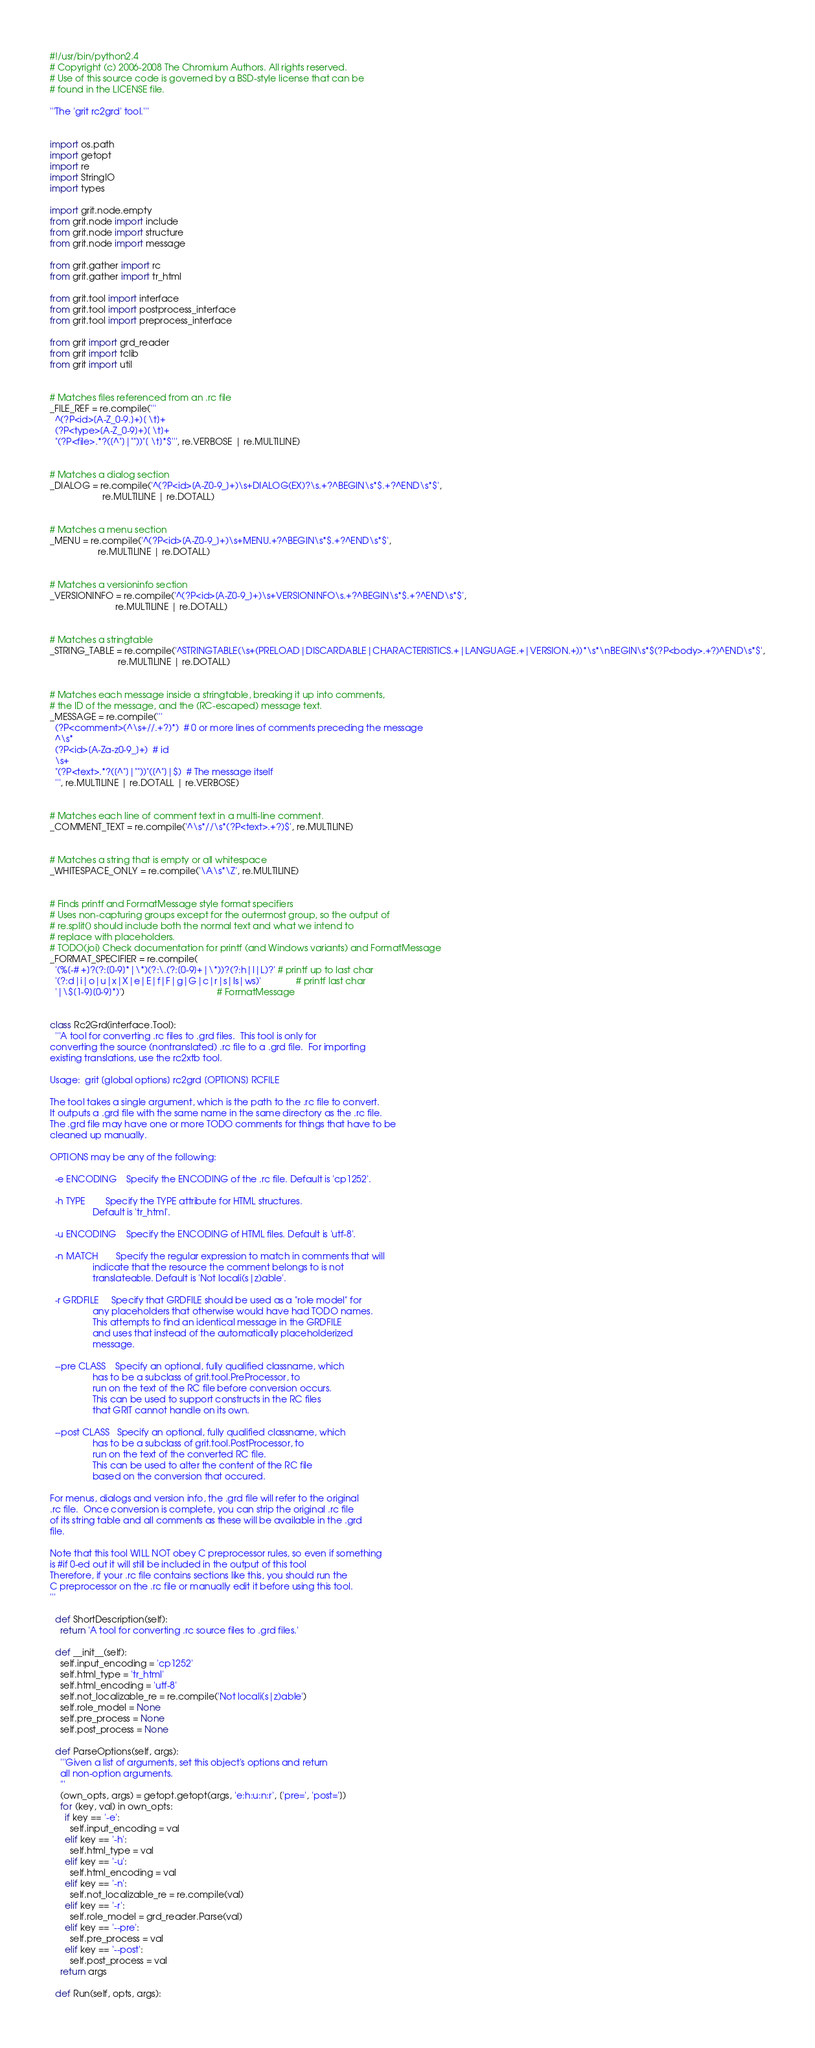Convert code to text. <code><loc_0><loc_0><loc_500><loc_500><_Python_>#!/usr/bin/python2.4
# Copyright (c) 2006-2008 The Chromium Authors. All rights reserved.
# Use of this source code is governed by a BSD-style license that can be
# found in the LICENSE file.

'''The 'grit rc2grd' tool.'''


import os.path
import getopt
import re
import StringIO
import types

import grit.node.empty
from grit.node import include
from grit.node import structure
from grit.node import message

from grit.gather import rc
from grit.gather import tr_html

from grit.tool import interface
from grit.tool import postprocess_interface
from grit.tool import preprocess_interface

from grit import grd_reader
from grit import tclib
from grit import util


# Matches files referenced from an .rc file
_FILE_REF = re.compile('''
  ^(?P<id>[A-Z_0-9.]+)[ \t]+
  (?P<type>[A-Z_0-9]+)[ \t]+
  "(?P<file>.*?([^"]|""))"[ \t]*$''', re.VERBOSE | re.MULTILINE)


# Matches a dialog section
_DIALOG = re.compile('^(?P<id>[A-Z0-9_]+)\s+DIALOG(EX)?\s.+?^BEGIN\s*$.+?^END\s*$',
                     re.MULTILINE | re.DOTALL)


# Matches a menu section
_MENU = re.compile('^(?P<id>[A-Z0-9_]+)\s+MENU.+?^BEGIN\s*$.+?^END\s*$',
                   re.MULTILINE | re.DOTALL)


# Matches a versioninfo section
_VERSIONINFO = re.compile('^(?P<id>[A-Z0-9_]+)\s+VERSIONINFO\s.+?^BEGIN\s*$.+?^END\s*$',
                          re.MULTILINE | re.DOTALL)


# Matches a stringtable
_STRING_TABLE = re.compile('^STRINGTABLE(\s+(PRELOAD|DISCARDABLE|CHARACTERISTICS.+|LANGUAGE.+|VERSION.+))*\s*\nBEGIN\s*$(?P<body>.+?)^END\s*$',
                           re.MULTILINE | re.DOTALL)


# Matches each message inside a stringtable, breaking it up into comments,
# the ID of the message, and the (RC-escaped) message text.
_MESSAGE = re.compile('''
  (?P<comment>(^\s+//.+?)*)  # 0 or more lines of comments preceding the message
  ^\s*
  (?P<id>[A-Za-z0-9_]+)  # id
  \s+
  "(?P<text>.*?([^"]|""))"([^"]|$)  # The message itself
  ''', re.MULTILINE | re.DOTALL | re.VERBOSE)


# Matches each line of comment text in a multi-line comment.
_COMMENT_TEXT = re.compile('^\s*//\s*(?P<text>.+?)$', re.MULTILINE)


# Matches a string that is empty or all whitespace
_WHITESPACE_ONLY = re.compile('\A\s*\Z', re.MULTILINE)


# Finds printf and FormatMessage style format specifiers
# Uses non-capturing groups except for the outermost group, so the output of
# re.split() should include both the normal text and what we intend to
# replace with placeholders.
# TODO(joi) Check documentation for printf (and Windows variants) and FormatMessage
_FORMAT_SPECIFIER = re.compile(
  '(%[-# +]?(?:[0-9]*|\*)(?:\.(?:[0-9]+|\*))?(?:h|l|L)?' # printf up to last char
  '(?:d|i|o|u|x|X|e|E|f|F|g|G|c|r|s|ls|ws)'              # printf last char
  '|\$[1-9][0-9]*)')                                     # FormatMessage


class Rc2Grd(interface.Tool):
  '''A tool for converting .rc files to .grd files.  This tool is only for
converting the source (nontranslated) .rc file to a .grd file.  For importing
existing translations, use the rc2xtb tool.

Usage:  grit [global options] rc2grd [OPTIONS] RCFILE

The tool takes a single argument, which is the path to the .rc file to convert.
It outputs a .grd file with the same name in the same directory as the .rc file.
The .grd file may have one or more TODO comments for things that have to be
cleaned up manually.

OPTIONS may be any of the following:

  -e ENCODING    Specify the ENCODING of the .rc file. Default is 'cp1252'.
  
  -h TYPE        Specify the TYPE attribute for HTML structures.
                 Default is 'tr_html'.

  -u ENCODING    Specify the ENCODING of HTML files. Default is 'utf-8'.

  -n MATCH       Specify the regular expression to match in comments that will
                 indicate that the resource the comment belongs to is not
                 translateable. Default is 'Not locali(s|z)able'.

  -r GRDFILE     Specify that GRDFILE should be used as a "role model" for
                 any placeholders that otherwise would have had TODO names.
                 This attempts to find an identical message in the GRDFILE
                 and uses that instead of the automatically placeholderized
                 message.

  --pre CLASS    Specify an optional, fully qualified classname, which
                 has to be a subclass of grit.tool.PreProcessor, to
                 run on the text of the RC file before conversion occurs.
                 This can be used to support constructs in the RC files
                 that GRIT cannot handle on its own.

  --post CLASS   Specify an optional, fully qualified classname, which
                 has to be a subclass of grit.tool.PostProcessor, to
                 run on the text of the converted RC file.
                 This can be used to alter the content of the RC file
                 based on the conversion that occured.

For menus, dialogs and version info, the .grd file will refer to the original
.rc file.  Once conversion is complete, you can strip the original .rc file
of its string table and all comments as these will be available in the .grd
file.

Note that this tool WILL NOT obey C preprocessor rules, so even if something
is #if 0-ed out it will still be included in the output of this tool
Therefore, if your .rc file contains sections like this, you should run the
C preprocessor on the .rc file or manually edit it before using this tool.
'''
  
  def ShortDescription(self):
    return 'A tool for converting .rc source files to .grd files.'
  
  def __init__(self):
    self.input_encoding = 'cp1252'
    self.html_type = 'tr_html'
    self.html_encoding = 'utf-8'
    self.not_localizable_re = re.compile('Not locali(s|z)able')
    self.role_model = None
    self.pre_process = None
    self.post_process = None
  
  def ParseOptions(self, args):
    '''Given a list of arguments, set this object's options and return
    all non-option arguments.
    '''
    (own_opts, args) = getopt.getopt(args, 'e:h:u:n:r', ['pre=', 'post='])
    for (key, val) in own_opts:
      if key == '-e':
        self.input_encoding = val
      elif key == '-h':
        self.html_type = val
      elif key == '-u':
        self.html_encoding = val
      elif key == '-n':
        self.not_localizable_re = re.compile(val)
      elif key == '-r':
        self.role_model = grd_reader.Parse(val)
      elif key == '--pre':
        self.pre_process = val
      elif key == '--post':
        self.post_process = val
    return args

  def Run(self, opts, args):</code> 